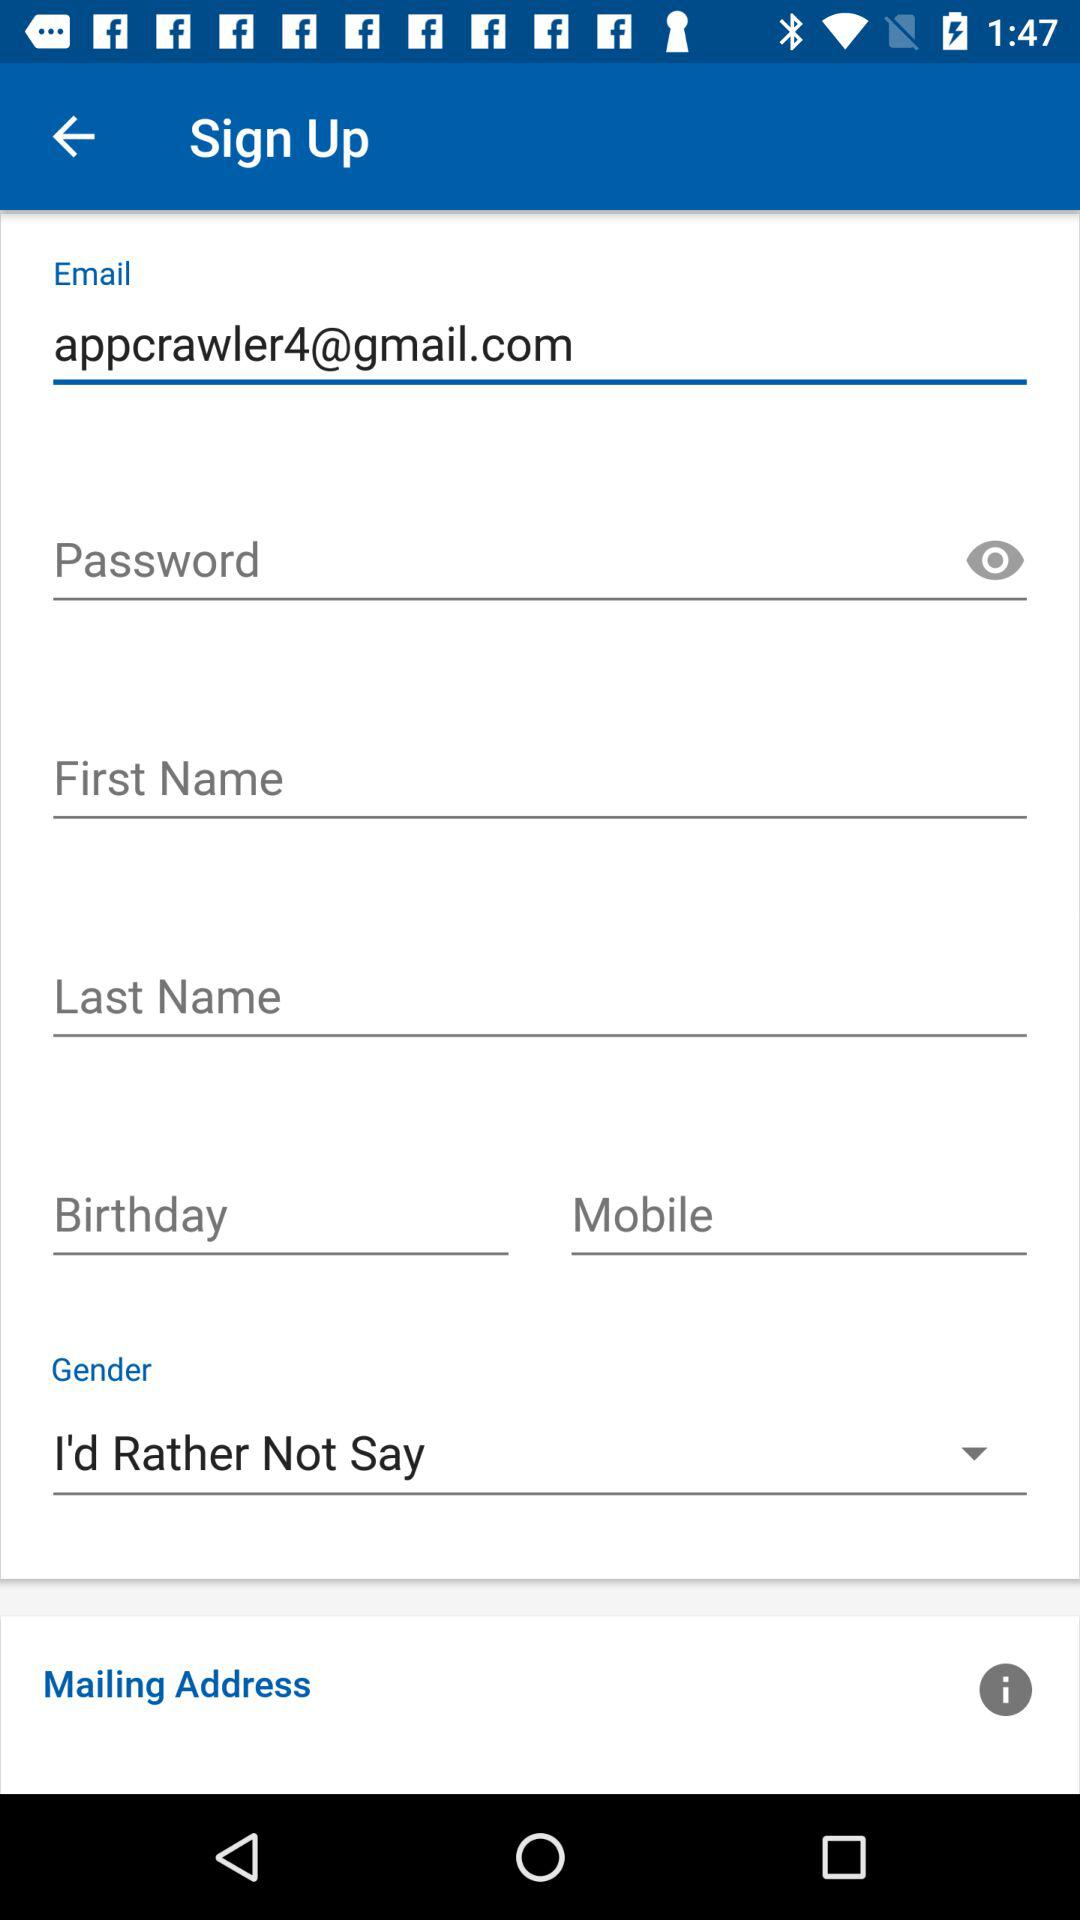What is the email address? The email address is appcrawler4@gmail.com. 